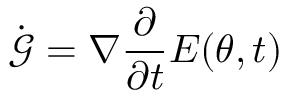<formula> <loc_0><loc_0><loc_500><loc_500>\dot { \mathcal { G } } = \nabla \frac { \partial } { \partial t } E ( { \theta } , t )</formula> 